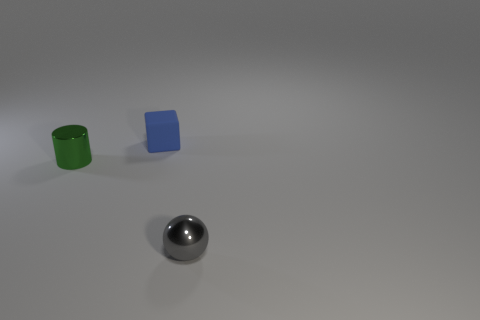What is the tiny thing that is both in front of the tiny matte block and right of the small green cylinder made of?
Your answer should be very brief. Metal. Are there fewer tiny gray metal balls than large brown rubber objects?
Make the answer very short. No. Does the metallic sphere in front of the blue block have the same size as the blue rubber block?
Offer a terse response. Yes. What is the shape of the metal object that is the same size as the gray metal ball?
Your answer should be compact. Cylinder. Is the small green object the same shape as the tiny gray shiny object?
Make the answer very short. No. What number of tiny rubber objects are the same shape as the small green metallic object?
Keep it short and to the point. 0. What number of green metallic things are left of the green metallic object?
Offer a terse response. 0. Is the color of the object in front of the green metal cylinder the same as the matte thing?
Make the answer very short. No. How many green cylinders have the same size as the sphere?
Provide a short and direct response. 1. There is another tiny object that is made of the same material as the green object; what shape is it?
Provide a short and direct response. Sphere. 